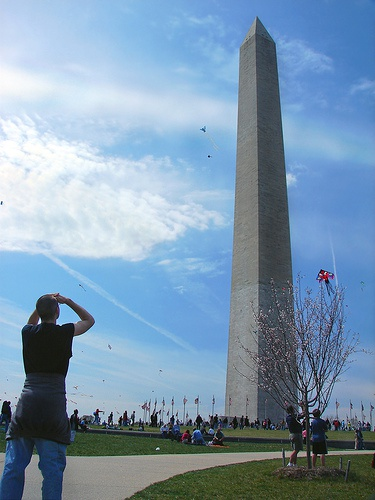Describe the objects in this image and their specific colors. I can see people in lavender, black, navy, gray, and blue tones, people in lavender, black, gray, darkgray, and darkgreen tones, kite in lavender, darkgray, white, gray, and lightblue tones, people in lavender, black, navy, gray, and maroon tones, and people in lavender, black, gray, maroon, and navy tones in this image. 